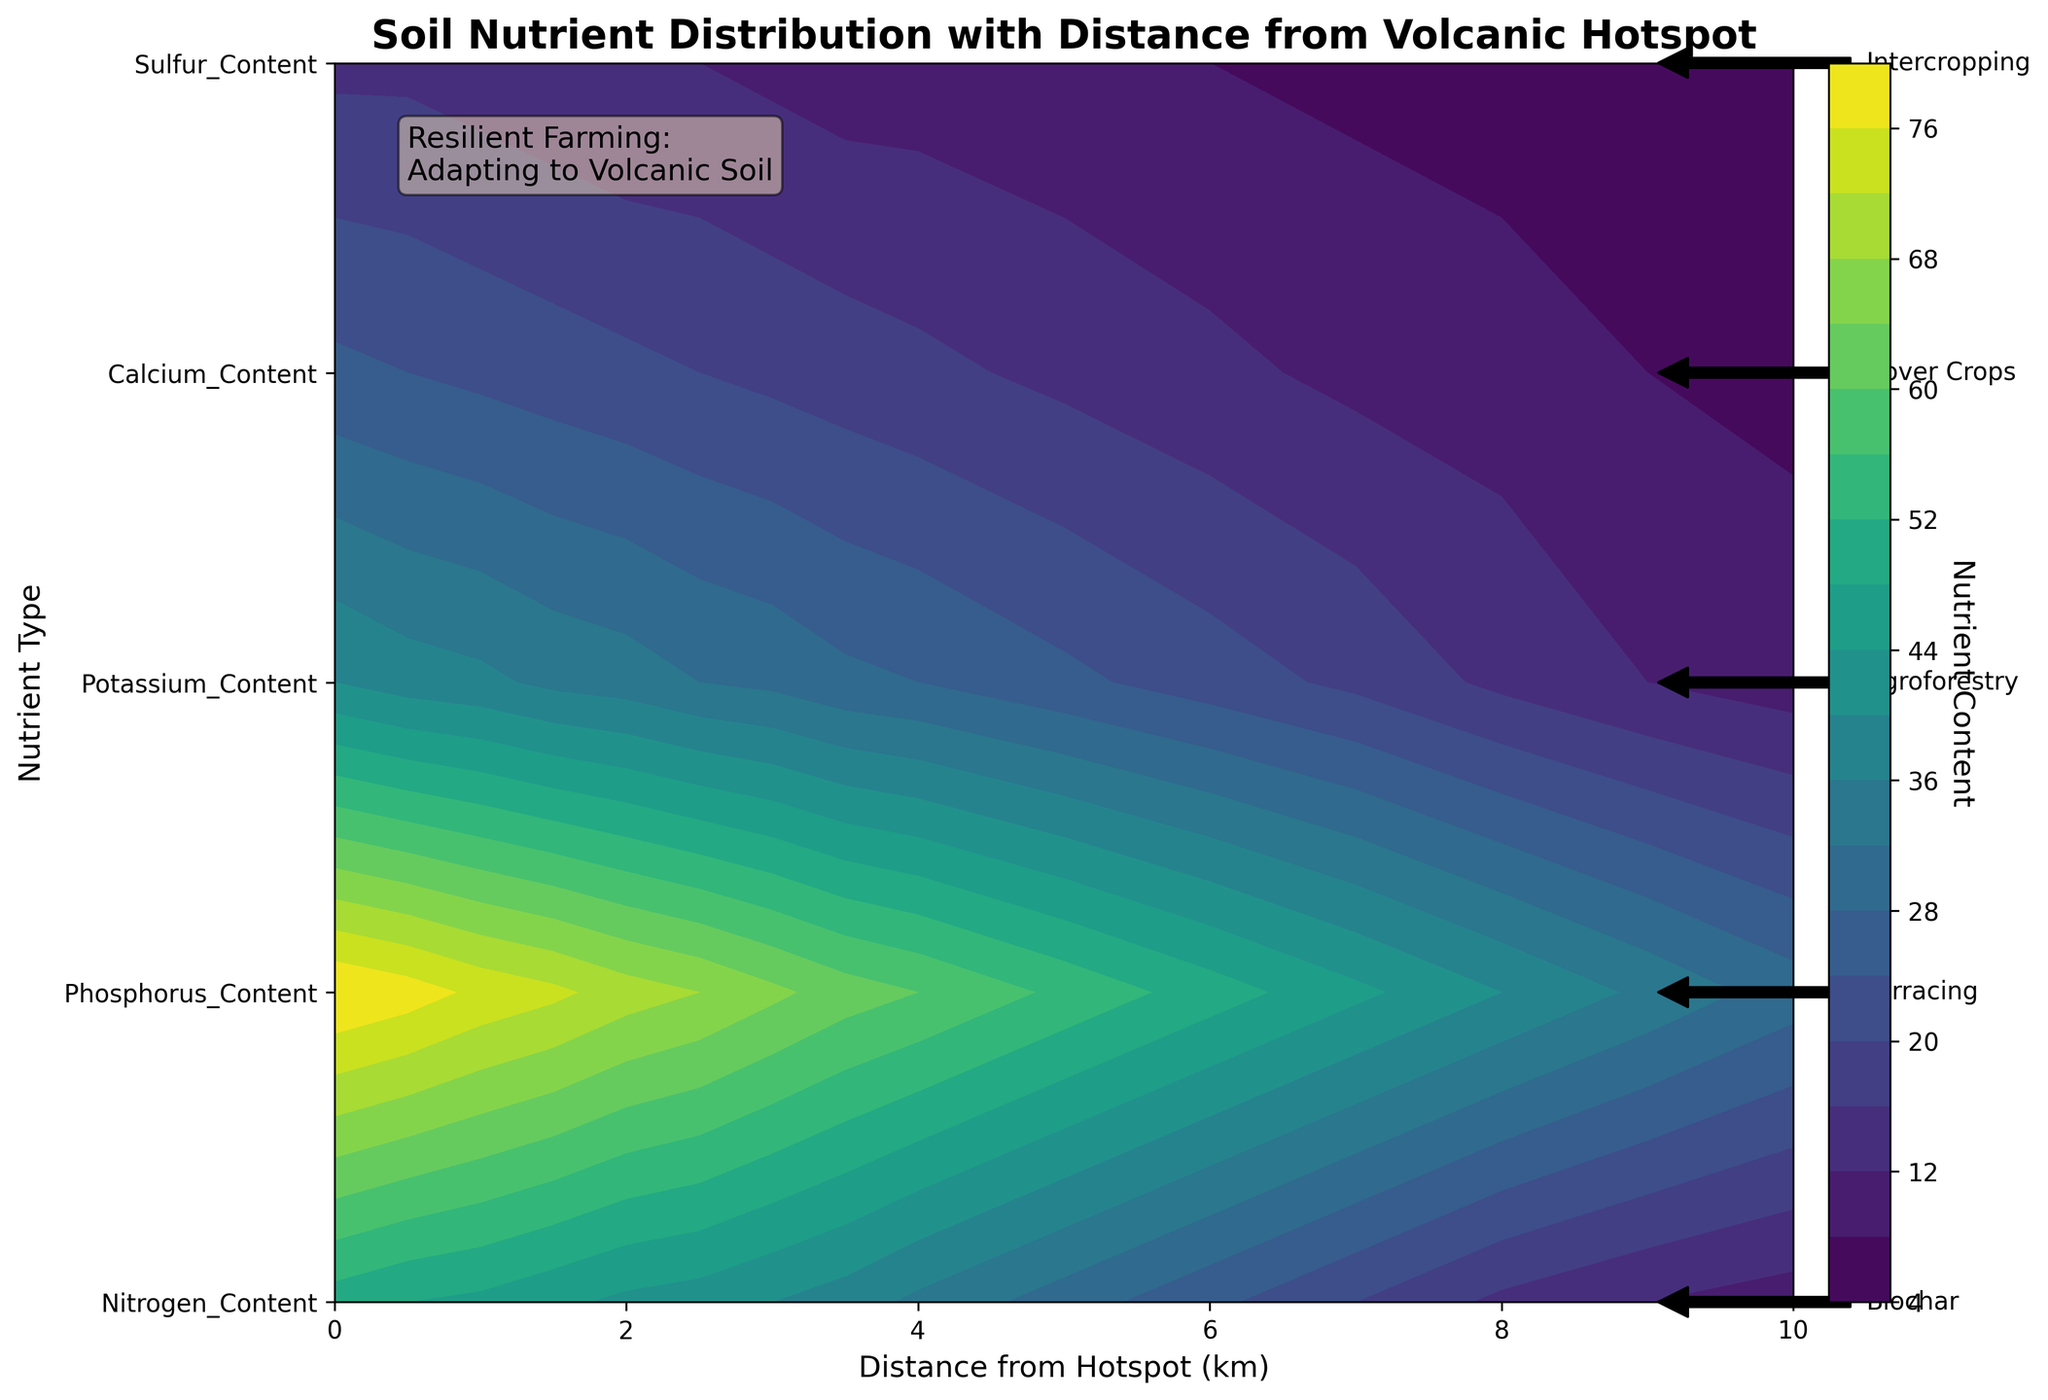What is the title of the plot? The title of the plot is usually found at the top of the figure. It is typically displayed in a larger and bold font.
Answer: Soil Nutrient Distribution with Distance from Volcanic Hotspot What are the units of the x-axis? The units of the x-axis are indicated along with the axis label. In this case, the x-axis is labeled 'Distance from Hotspot' followed by the units in parentheses.
Answer: km What are the different nutrients shown on the y-axis? The y-axis labels have the different nutrient types listed vertically. The labels are clearly presented and distinguishable.
Answer: Nitrogen, Phosphorus, Potassium, Calcium, Sulfur At what distance from the hotspot does Nitrogen have the highest concentration? Locate the contour color corresponding to the highest concentration level and map it to the distance from hotspot for the Nitrogen label. The highest concentration is found at the beginning of the gradient, nearest to the hotspot.
Answer: 0 km How does Phosphorus content change as you move away from the hotspot? To answer how the content changes, follow the color gradient of Phosphorus across the x-axis. Observe the trend starting from the leftmost side to the rightmost side of the figure. The color representing concentration decreases from higher intensity near the hotspot to a lower intensity further away.
Answer: Decreases Which nutrient shows the most significant decrease within 5 km from the hotspot? Compare the contours of each nutrient from 0 to 5 km. The nutrient showing the most notable color transition to lighter shades indicates a significant decrease.
Answer: Nitrogen What innovative farming technique is indicated near the Sulfur label? The Sulfur label is located on the y-axis, and annotations near this label are the identified technique. Follow the annotation arrows and notes on the right side from the Sulfur's approximate y-axis position.
Answer: Intercropping Which nutrient has the lowest content at 10 km away from the hotspot? Find the rightmost section for each nutrient (at 10 km). Check the color gradient; the nutrient with the lowest intensity (suggesting the smallest value) will be the lowest content one.
Answer: Calcium What is the concentration level of Potassium at 4 km from the hotspot? Locate the 4 km mark on the x-axis, then find the color gradient at the intersection with the Potassium label on the y-axis. Refer to the color bar to determine the corresponding concentration level.
Answer: 28 Which nutrient's variance appears smallest across all distances from the hotspot? Examine the contour density and the spread of color variations for each nutrient. If one nutrient's color remains more constant without significant changes, its variance is the smallest.
Answer: Sulfur 